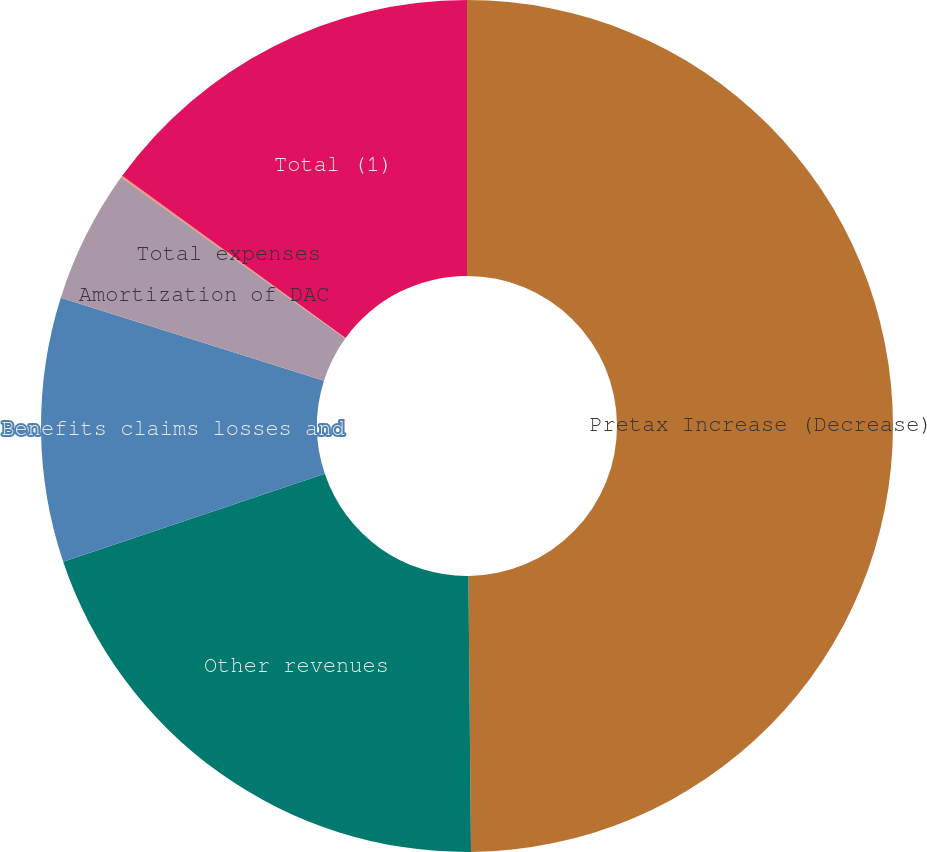<chart> <loc_0><loc_0><loc_500><loc_500><pie_chart><fcel>Pretax Increase (Decrease)<fcel>Other revenues<fcel>Benefits claims losses and<fcel>Amortization of DAC<fcel>Total expenses<fcel>Total (1)<nl><fcel>49.85%<fcel>19.99%<fcel>10.03%<fcel>5.05%<fcel>0.07%<fcel>15.01%<nl></chart> 